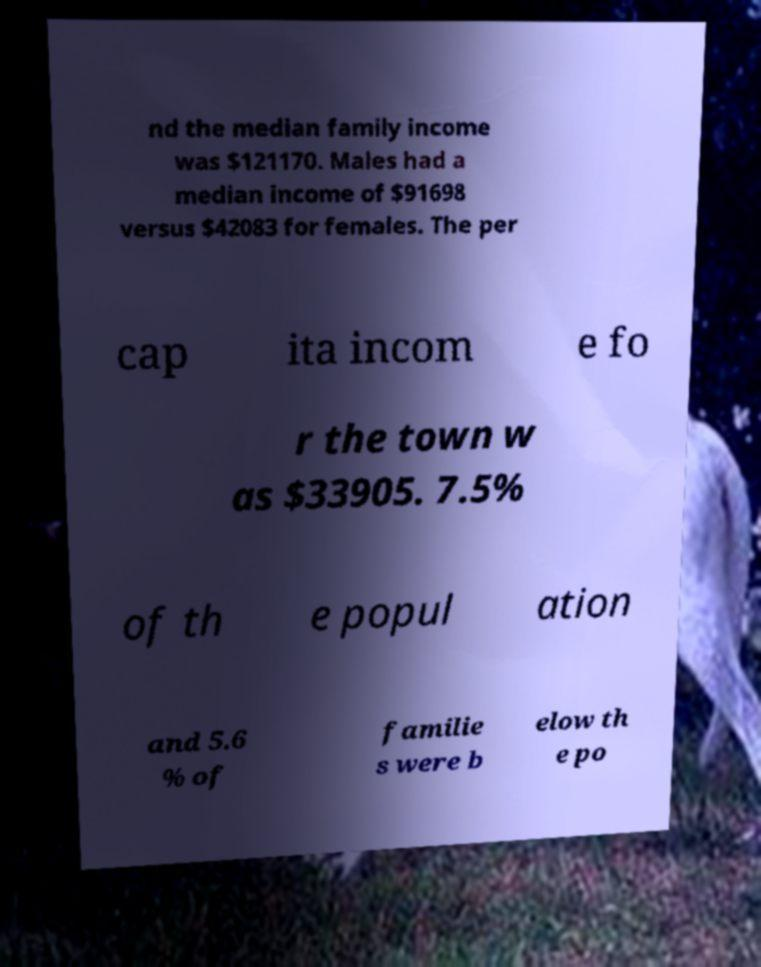Could you assist in decoding the text presented in this image and type it out clearly? nd the median family income was $121170. Males had a median income of $91698 versus $42083 for females. The per cap ita incom e fo r the town w as $33905. 7.5% of th e popul ation and 5.6 % of familie s were b elow th e po 